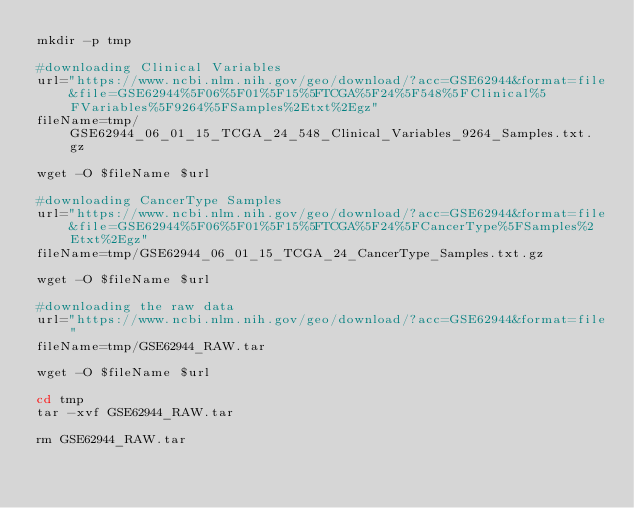<code> <loc_0><loc_0><loc_500><loc_500><_Bash_>mkdir -p tmp

#downloading Clinical Variables
url="https://www.ncbi.nlm.nih.gov/geo/download/?acc=GSE62944&format=file&file=GSE62944%5F06%5F01%5F15%5FTCGA%5F24%5F548%5FClinical%5FVariables%5F9264%5FSamples%2Etxt%2Egz"
fileName=tmp/GSE62944_06_01_15_TCGA_24_548_Clinical_Variables_9264_Samples.txt.gz

wget -O $fileName $url

#downloading CancerType Samples
url="https://www.ncbi.nlm.nih.gov/geo/download/?acc=GSE62944&format=file&file=GSE62944%5F06%5F01%5F15%5FTCGA%5F24%5FCancerType%5FSamples%2Etxt%2Egz"
fileName=tmp/GSE62944_06_01_15_TCGA_24_CancerType_Samples.txt.gz

wget -O $fileName $url

#downloading the raw data
url="https://www.ncbi.nlm.nih.gov/geo/download/?acc=GSE62944&format=file"
fileName=tmp/GSE62944_RAW.tar

wget -O $fileName $url

cd tmp
tar -xvf GSE62944_RAW.tar

rm GSE62944_RAW.tar
</code> 